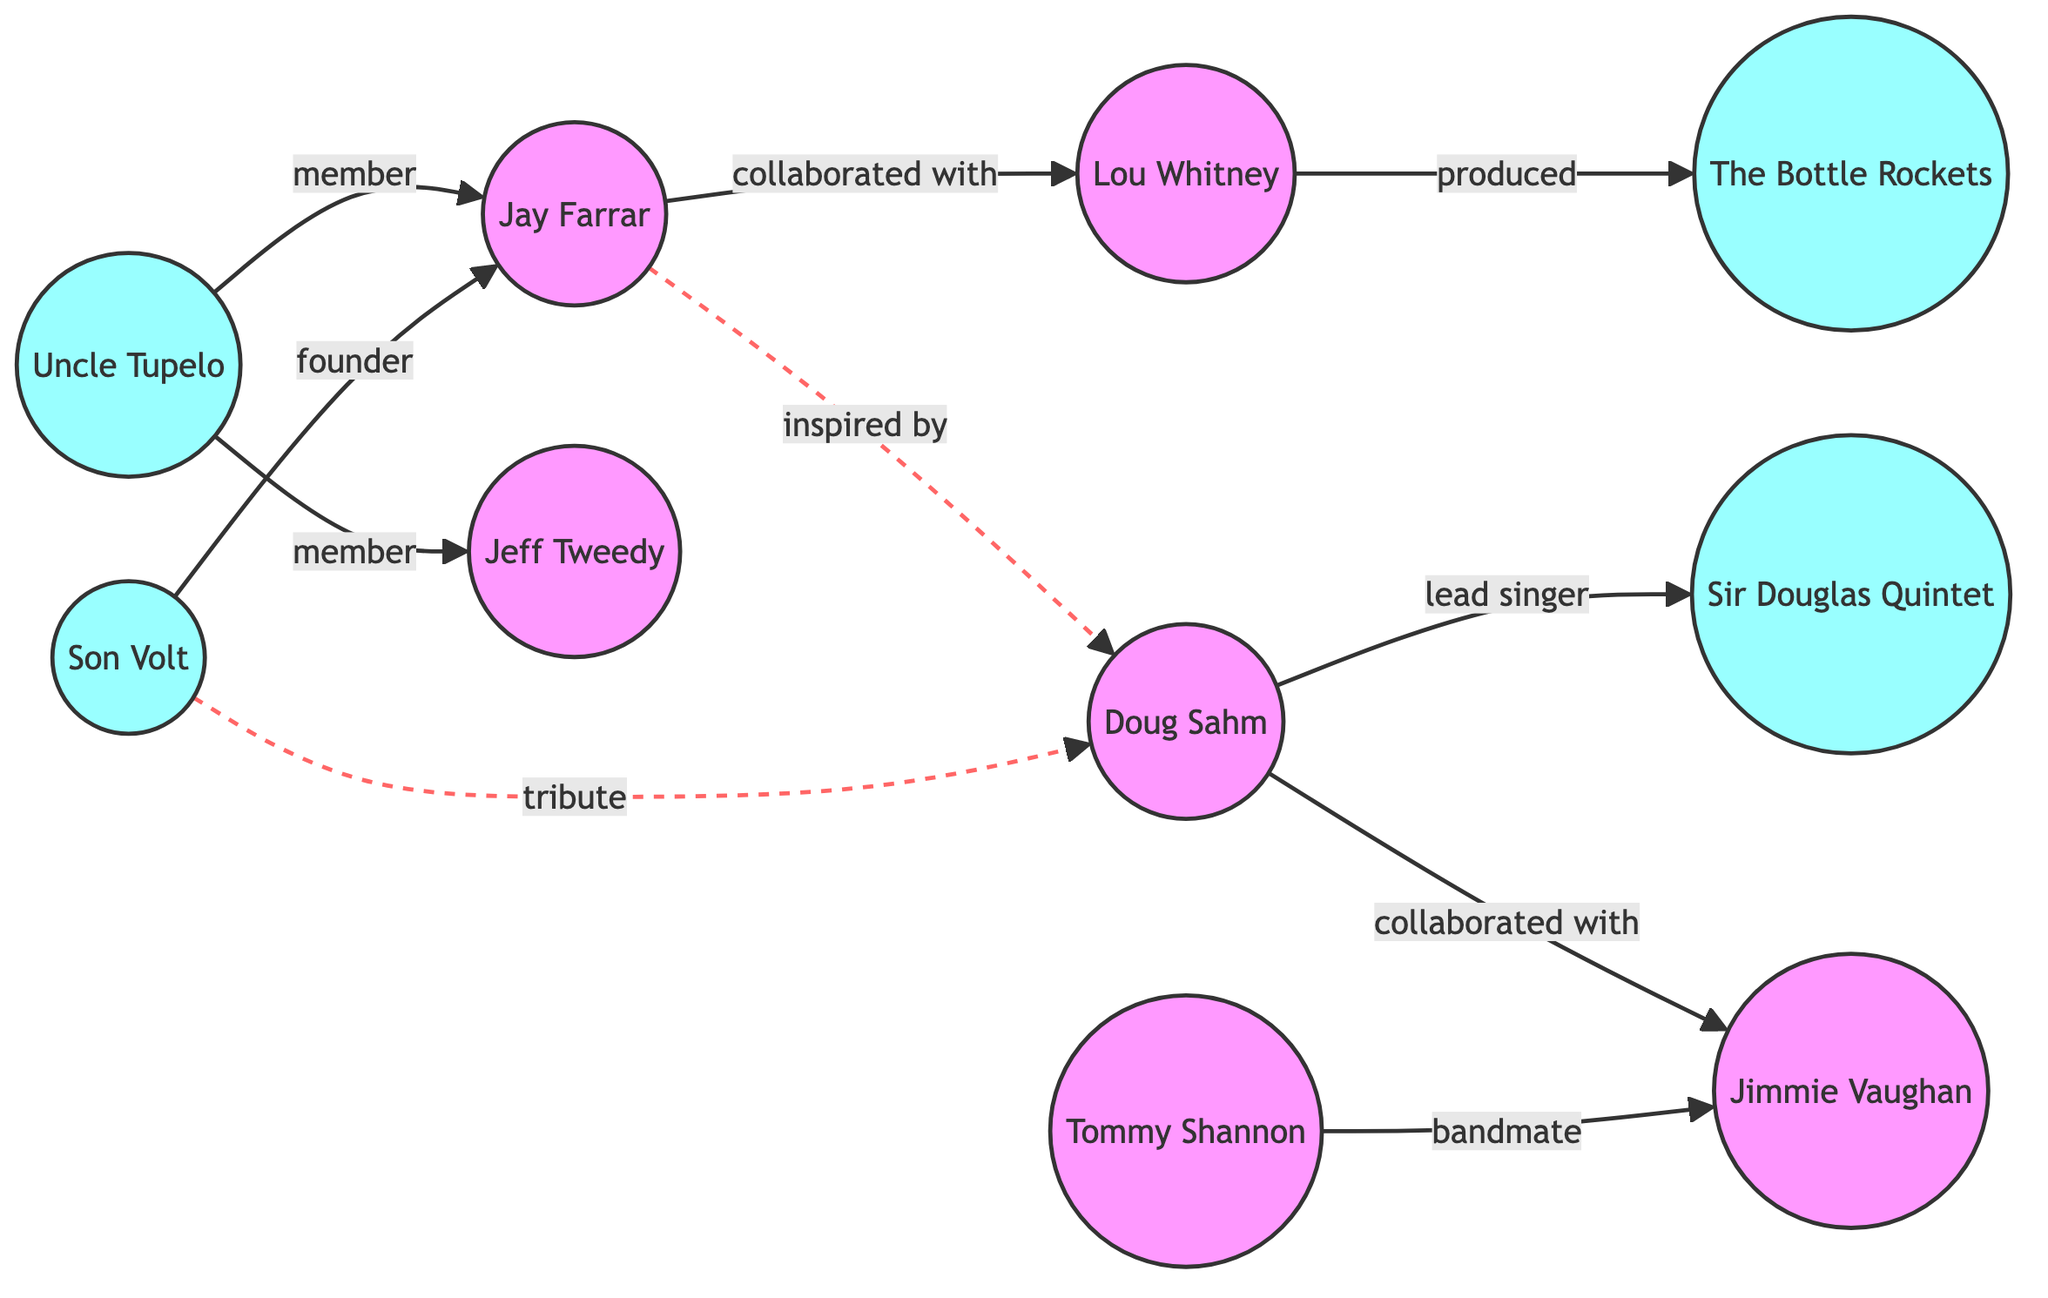What is the total number of nodes in the diagram? By counting the entries under the "nodes" section, we identify 10 unique entities: Doug Sahm, Son Volt, Jay Farrar, Jeff Tweedy, Lou Whitney, The Bottle Rockets, Uncle Tupelo, Sir Douglas Quintet, Jimmie Vaughan, and Tommy Shannon. Adding these together gives us 10.
Answer: 10 Which band was founded by Jay Farrar? The edge from Son Volt to Jay Farrar indicates that Son Volt is the band founded by Jay Farrar. This directly provides the answer without ambiguity.
Answer: Son Volt Who collaborated with Lou Whitney? The directed edge from Jay Farrar to Lou Whitney specifically states that Jay Farrar collaborated with Lou Whitney, making this a straightforward connection to follow.
Answer: Jay Farrar How many members were in Uncle Tupelo? The diagram shows two edges leading from Uncle Tupelo to both Jay Farrar and Jeff Tweedy, indicating that both are members of Uncle Tupelo. Hence, the number of members is counted as 2.
Answer: 2 What relationship did Doug Sahm have with the Sir Douglas Quintet? The diagram includes a direct edge from Doug Sahm to Sir Douglas Quintet labeled "lead singer," clearly defining the nature of his involvement with that band.
Answer: lead singer What does the relationship between Son Volt and Doug Sahm signify? The relationship labeled "tribute" from Son Volt to Doug Sahm indicates that Son Volt pays tribute to Doug Sahm, which reflects a respectful acknowledgment of his influence.
Answer: tribute Which artist is connected to Jimmie Vaughan through Tommy Shannon? The edge from Tommy Shannon to Jimmie Vaughan labeled "bandmate" denotes that there is a bandmate relationship relevant to this connection. Thus, Tommy Shannon connects to Jimmie Vaughan.
Answer: Tommy Shannon Who was inspired by Doug Sahm? The directed, dashed edge from Jay Farrar to Doug Sahm labeled "inspired by" implies that Jay Farrar found inspiration from Doug Sahm, making Jay Farrar the answer.
Answer: Jay Farrar Name a band that Lou Whitney produced. The directed edge from Lou Whitney to The Bottle Rockets indicates a specific production relationship, which directly leads to The Bottle Rockets as the entity produced.
Answer: The Bottle Rockets 